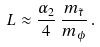<formula> <loc_0><loc_0><loc_500><loc_500>L \approx \frac { \alpha _ { 2 } } { 4 } \, \frac { m _ { \tilde { \tau } } } { m _ { \phi } } \, .</formula> 